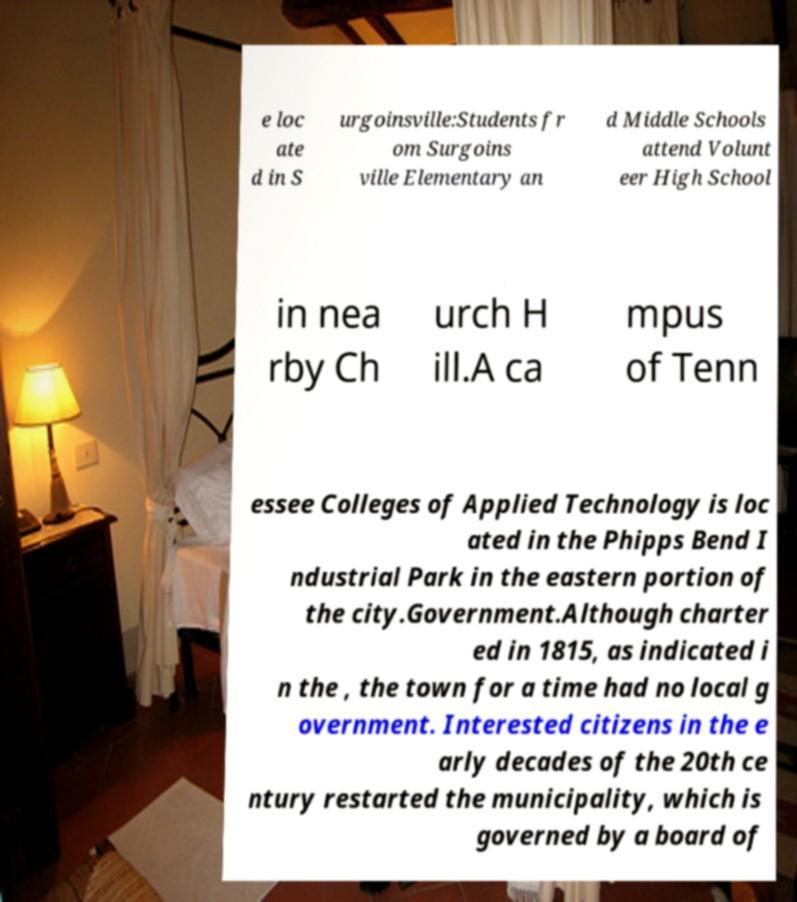Please identify and transcribe the text found in this image. e loc ate d in S urgoinsville:Students fr om Surgoins ville Elementary an d Middle Schools attend Volunt eer High School in nea rby Ch urch H ill.A ca mpus of Tenn essee Colleges of Applied Technology is loc ated in the Phipps Bend I ndustrial Park in the eastern portion of the city.Government.Although charter ed in 1815, as indicated i n the , the town for a time had no local g overnment. Interested citizens in the e arly decades of the 20th ce ntury restarted the municipality, which is governed by a board of 